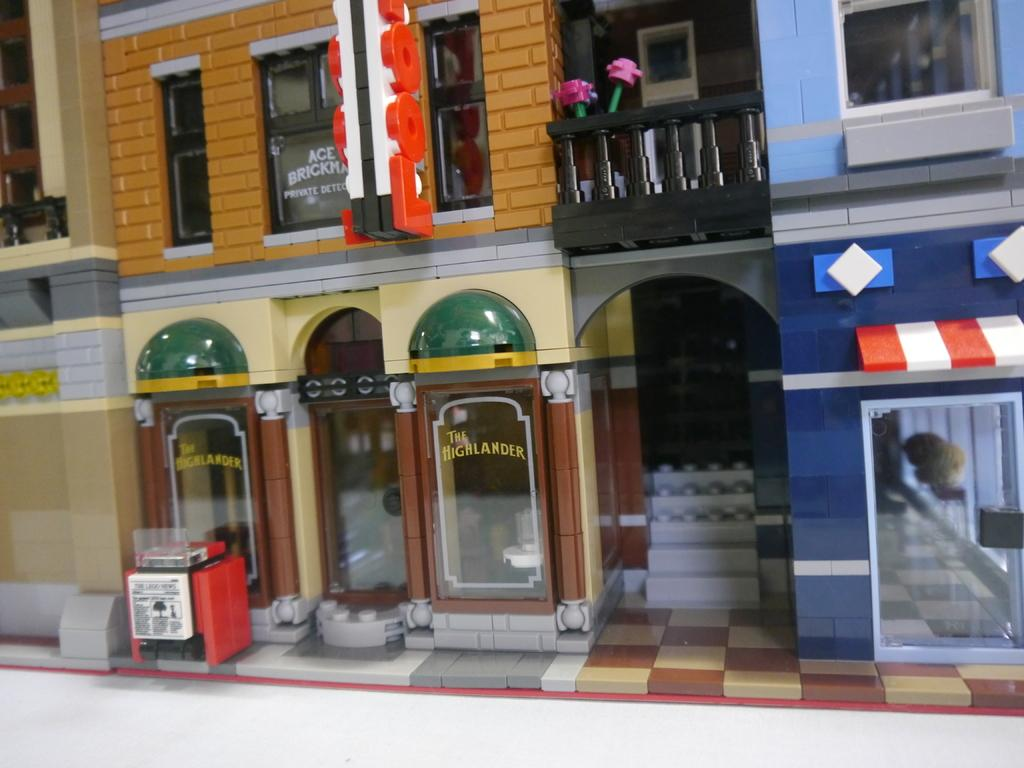Provide a one-sentence caption for the provided image. A lego city with a small cafe called The Highlander sits below two pink lego flowers. 